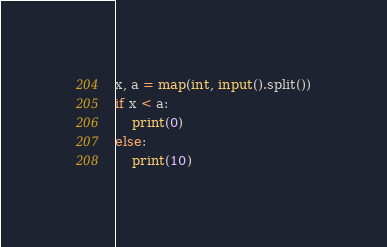Convert code to text. <code><loc_0><loc_0><loc_500><loc_500><_Python_>x, a = map(int, input().split())
if x < a:
    print(0)
else:
    print(10)
</code> 